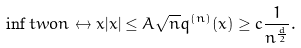Convert formula to latex. <formula><loc_0><loc_0><loc_500><loc_500>\inf t w o { n \leftrightarrow x } { | x | \leq A \sqrt { n } } q ^ { ( n ) } ( x ) \geq c \frac { 1 } { n ^ { \frac { d } { 2 } } } .</formula> 